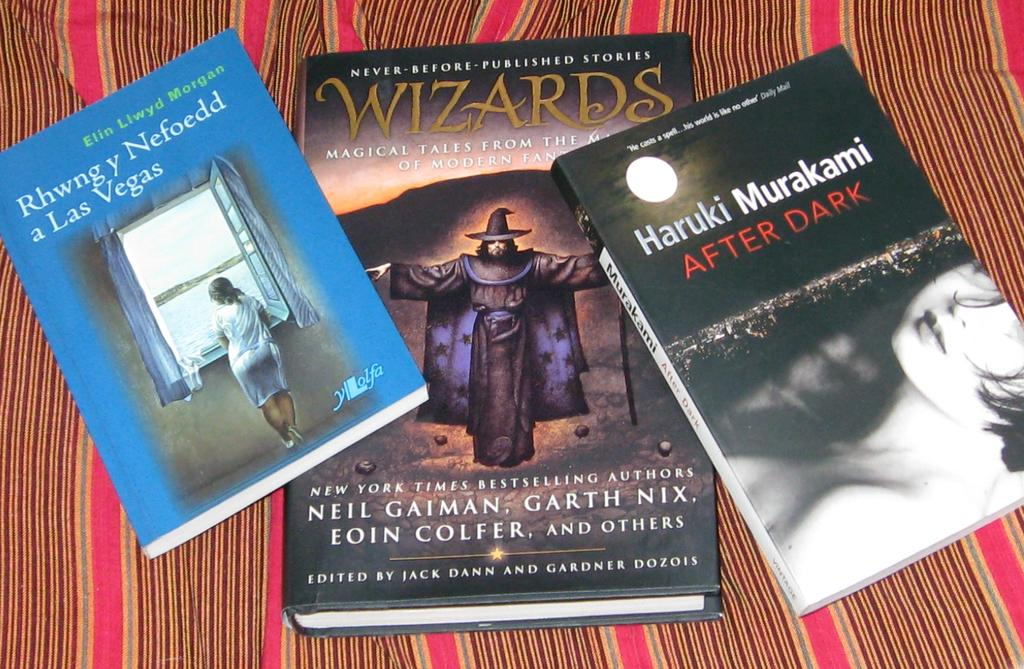Provide a one-sentence caption for the provided image. Three books lying on a bed sheet, the book on the right is After Dark, by Haruki Murakami. 